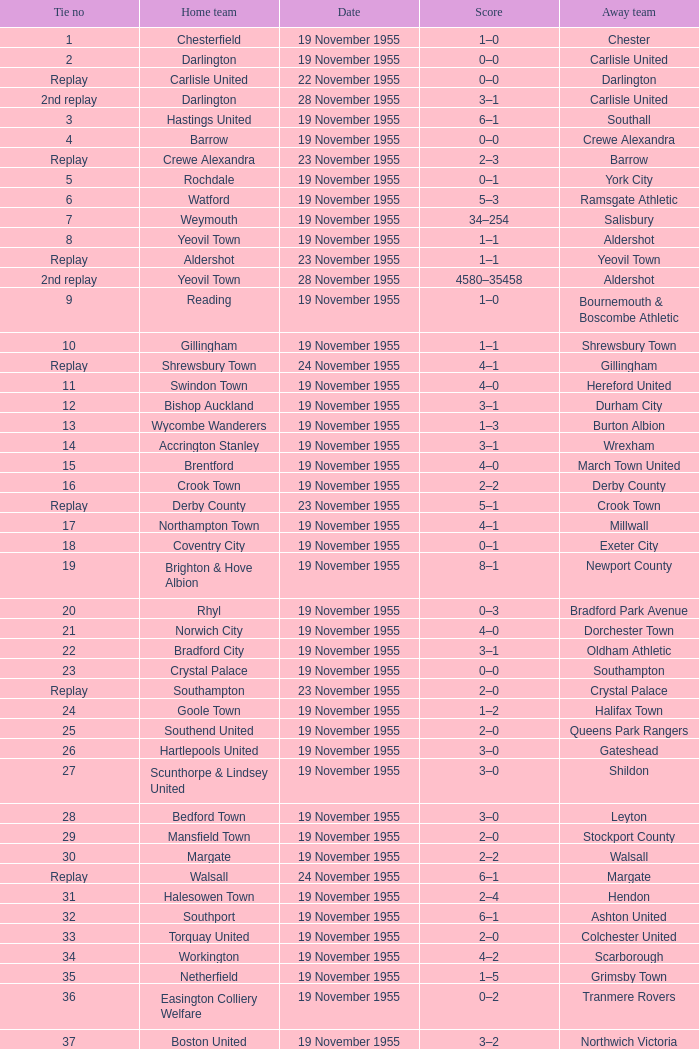What is the home team with scarborough as the away team? Workington. 